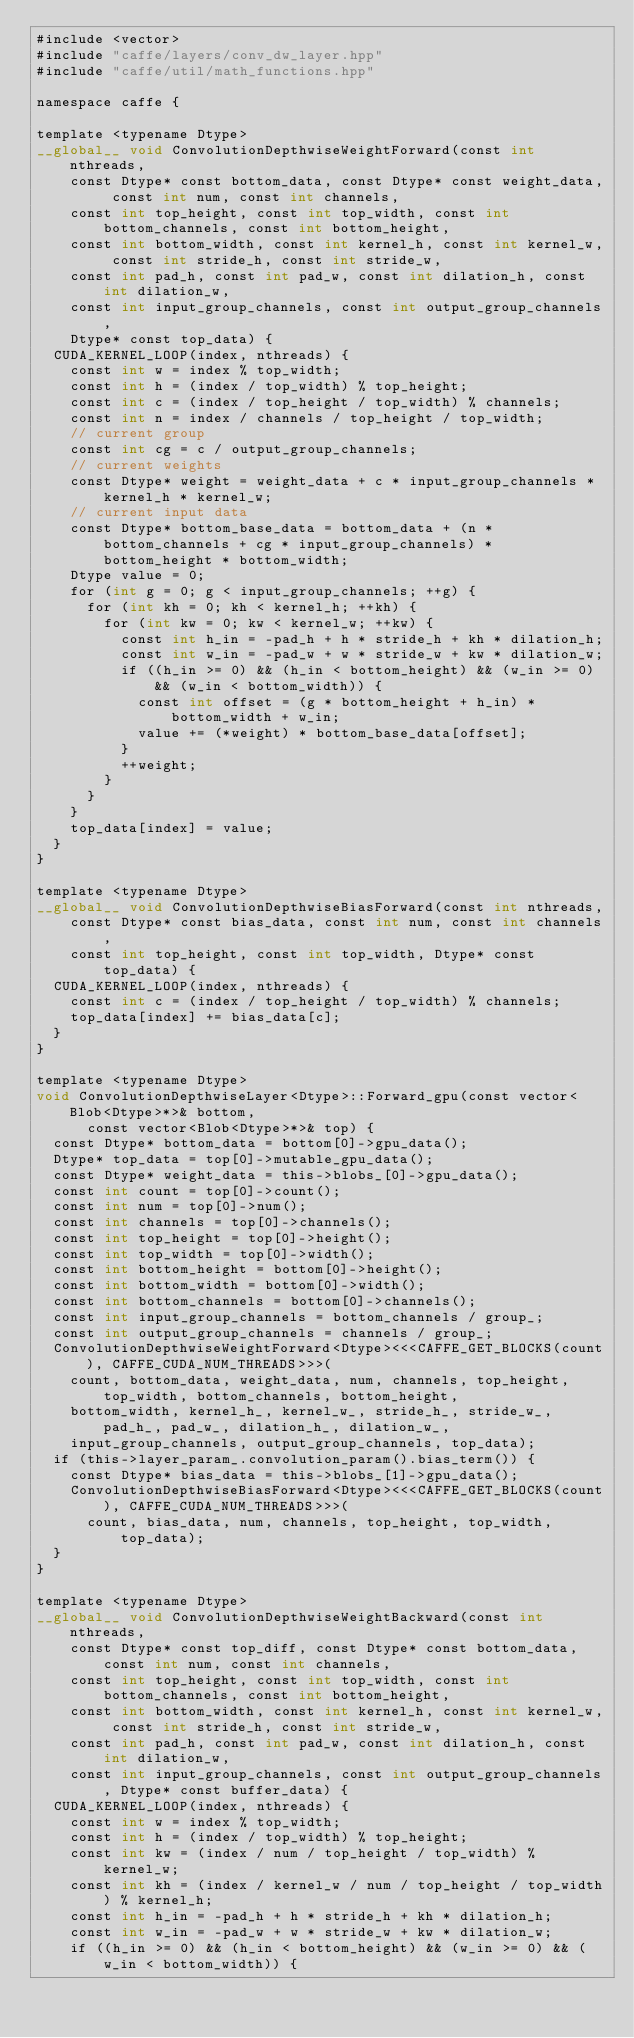<code> <loc_0><loc_0><loc_500><loc_500><_Cuda_>#include <vector>
#include "caffe/layers/conv_dw_layer.hpp"
#include "caffe/util/math_functions.hpp"

namespace caffe {

template <typename Dtype>
__global__ void ConvolutionDepthwiseWeightForward(const int nthreads,
    const Dtype* const bottom_data, const Dtype* const weight_data, const int num, const int channels,
    const int top_height, const int top_width, const int bottom_channels, const int bottom_height,
    const int bottom_width, const int kernel_h, const int kernel_w, const int stride_h, const int stride_w,
    const int pad_h, const int pad_w, const int dilation_h, const int dilation_w,
    const int input_group_channels, const int output_group_channels,
    Dtype* const top_data) {
  CUDA_KERNEL_LOOP(index, nthreads) {
    const int w = index % top_width;
    const int h = (index / top_width) % top_height;
    const int c = (index / top_height / top_width) % channels;
    const int n = index / channels / top_height / top_width;
    // current group
    const int cg = c / output_group_channels;
    // current weights
    const Dtype* weight = weight_data + c * input_group_channels * kernel_h * kernel_w;
    // current input data
    const Dtype* bottom_base_data = bottom_data + (n * bottom_channels + cg * input_group_channels) * bottom_height * bottom_width;
    Dtype value = 0;
    for (int g = 0; g < input_group_channels; ++g) {
      for (int kh = 0; kh < kernel_h; ++kh) {
        for (int kw = 0; kw < kernel_w; ++kw) {
          const int h_in = -pad_h + h * stride_h + kh * dilation_h;
          const int w_in = -pad_w + w * stride_w + kw * dilation_w;
          if ((h_in >= 0) && (h_in < bottom_height) && (w_in >= 0) && (w_in < bottom_width)) {
            const int offset = (g * bottom_height + h_in) * bottom_width + w_in;
            value += (*weight) * bottom_base_data[offset];
          }
          ++weight;
        }
      }
    }
    top_data[index] = value;
  }
}

template <typename Dtype>
__global__ void ConvolutionDepthwiseBiasForward(const int nthreads,
    const Dtype* const bias_data, const int num, const int channels,
    const int top_height, const int top_width, Dtype* const top_data) {
  CUDA_KERNEL_LOOP(index, nthreads) {
    const int c = (index / top_height / top_width) % channels;
    top_data[index] += bias_data[c];
  }
}

template <typename Dtype>
void ConvolutionDepthwiseLayer<Dtype>::Forward_gpu(const vector<Blob<Dtype>*>& bottom,
      const vector<Blob<Dtype>*>& top) {
  const Dtype* bottom_data = bottom[0]->gpu_data();
  Dtype* top_data = top[0]->mutable_gpu_data();
  const Dtype* weight_data = this->blobs_[0]->gpu_data();
  const int count = top[0]->count();
  const int num = top[0]->num();
  const int channels = top[0]->channels();
  const int top_height = top[0]->height();
  const int top_width = top[0]->width();
  const int bottom_height = bottom[0]->height();
  const int bottom_width = bottom[0]->width();
  const int bottom_channels = bottom[0]->channels();
  const int input_group_channels = bottom_channels / group_;
  const int output_group_channels = channels / group_;
  ConvolutionDepthwiseWeightForward<Dtype><<<CAFFE_GET_BLOCKS(count), CAFFE_CUDA_NUM_THREADS>>>(
    count, bottom_data, weight_data, num, channels, top_height, top_width, bottom_channels, bottom_height,
    bottom_width, kernel_h_, kernel_w_, stride_h_, stride_w_, pad_h_, pad_w_, dilation_h_, dilation_w_,
    input_group_channels, output_group_channels, top_data);
  if (this->layer_param_.convolution_param().bias_term()) {
    const Dtype* bias_data = this->blobs_[1]->gpu_data();
    ConvolutionDepthwiseBiasForward<Dtype><<<CAFFE_GET_BLOCKS(count), CAFFE_CUDA_NUM_THREADS>>>(
      count, bias_data, num, channels, top_height, top_width, top_data);
  }
}

template <typename Dtype>
__global__ void ConvolutionDepthwiseWeightBackward(const int nthreads,
    const Dtype* const top_diff, const Dtype* const bottom_data, const int num, const int channels,
    const int top_height, const int top_width, const int bottom_channels, const int bottom_height,
    const int bottom_width, const int kernel_h, const int kernel_w, const int stride_h, const int stride_w,
    const int pad_h, const int pad_w, const int dilation_h, const int dilation_w,
    const int input_group_channels, const int output_group_channels, Dtype* const buffer_data) {
  CUDA_KERNEL_LOOP(index, nthreads) {
    const int w = index % top_width;
    const int h = (index / top_width) % top_height;
    const int kw = (index / num / top_height / top_width) % kernel_w;
    const int kh = (index / kernel_w / num / top_height / top_width) % kernel_h;
    const int h_in = -pad_h + h * stride_h + kh * dilation_h;
    const int w_in = -pad_w + w * stride_w + kw * dilation_w;
    if ((h_in >= 0) && (h_in < bottom_height) && (w_in >= 0) && (w_in < bottom_width)) {</code> 